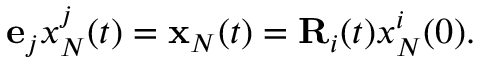Convert formula to latex. <formula><loc_0><loc_0><loc_500><loc_500>\begin{array} { r } { { e } _ { j } x _ { N } ^ { j } ( t ) = { x } _ { N } ( t ) = { R } _ { i } ( t ) x _ { N } ^ { i } ( 0 ) . } \end{array}</formula> 